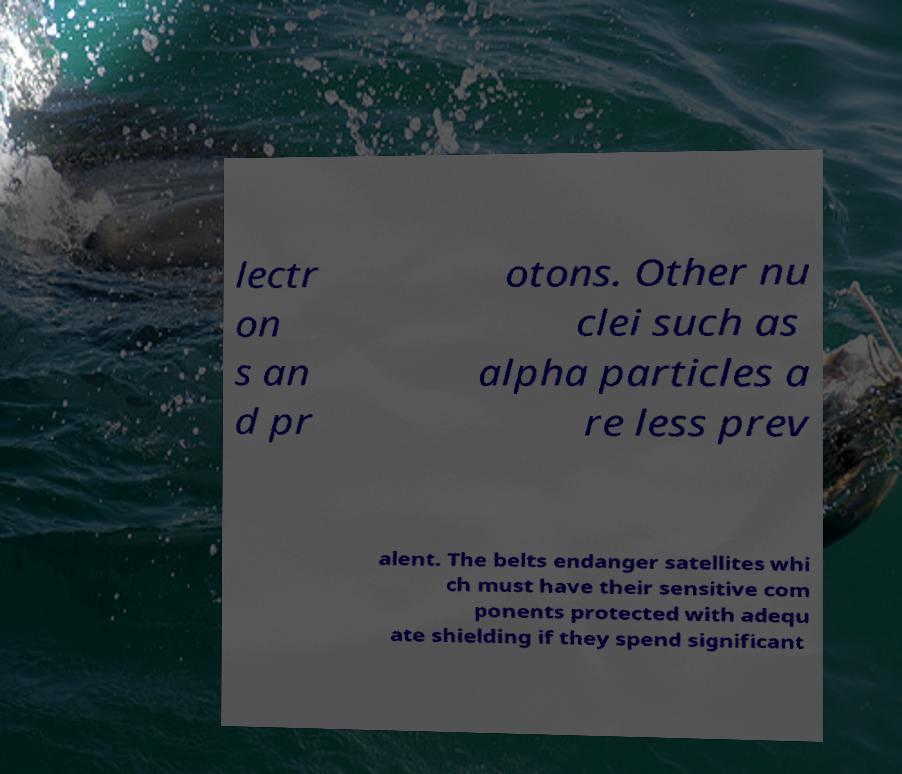What messages or text are displayed in this image? I need them in a readable, typed format. lectr on s an d pr otons. Other nu clei such as alpha particles a re less prev alent. The belts endanger satellites whi ch must have their sensitive com ponents protected with adequ ate shielding if they spend significant 